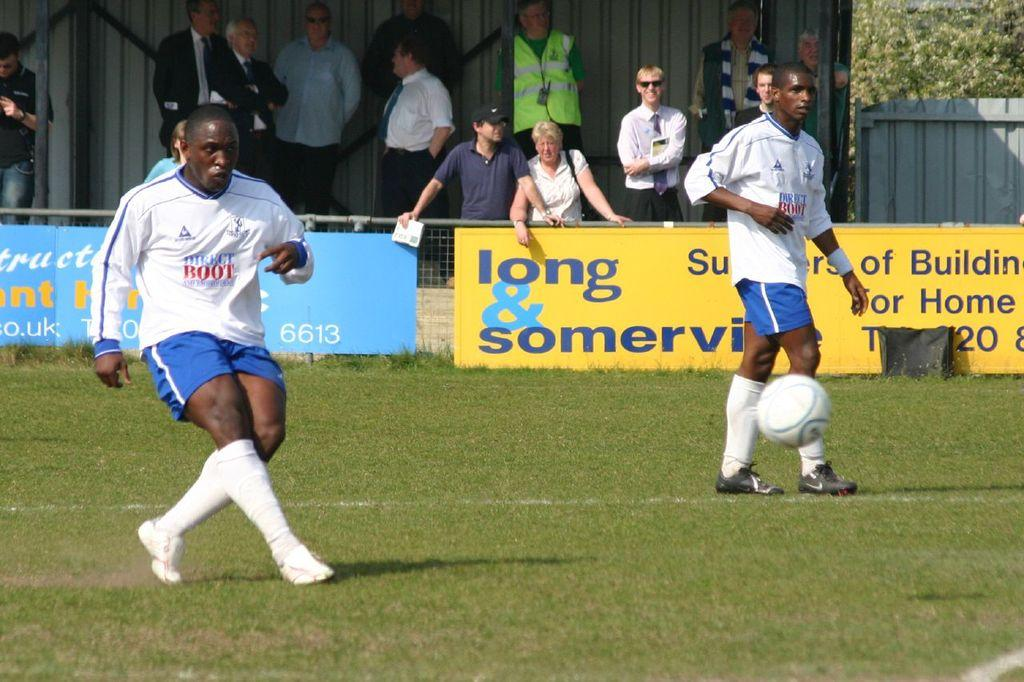<image>
Describe the image concisely. two soccer players on the field wearing white and blue uniforms with the word ROOT written in red across the chest 